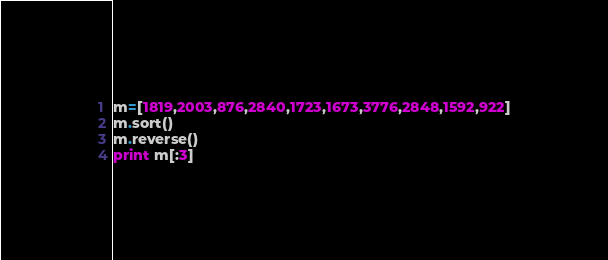<code> <loc_0><loc_0><loc_500><loc_500><_Python_>m=[1819,2003,876,2840,1723,1673,3776,2848,1592,922]
m.sort()
m.reverse()
print m[:3]</code> 